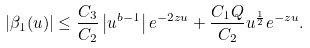<formula> <loc_0><loc_0><loc_500><loc_500>| \beta _ { 1 } ( u ) | \leq \frac { C _ { 3 } } { C _ { 2 } } \left | u ^ { b - 1 } \right | e ^ { - 2 z u } + \frac { C _ { 1 } Q } { C _ { 2 } } u ^ { \frac { 1 } { 2 } } e ^ { - z u } .</formula> 